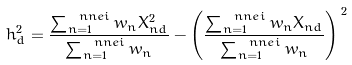<formula> <loc_0><loc_0><loc_500><loc_500>h _ { d } ^ { 2 } = \frac { \sum _ { n = 1 } ^ { \ n n e i } w _ { n } X _ { n d } ^ { 2 } } { \sum _ { n = 1 } ^ { \ n n e i } w _ { n } } - \left ( \frac { \sum _ { n = 1 } ^ { \ n n e i } w _ { n } X _ { n d } } { \sum _ { n = 1 } ^ { \ n n e i } w _ { n } } \right ) ^ { \, 2 }</formula> 